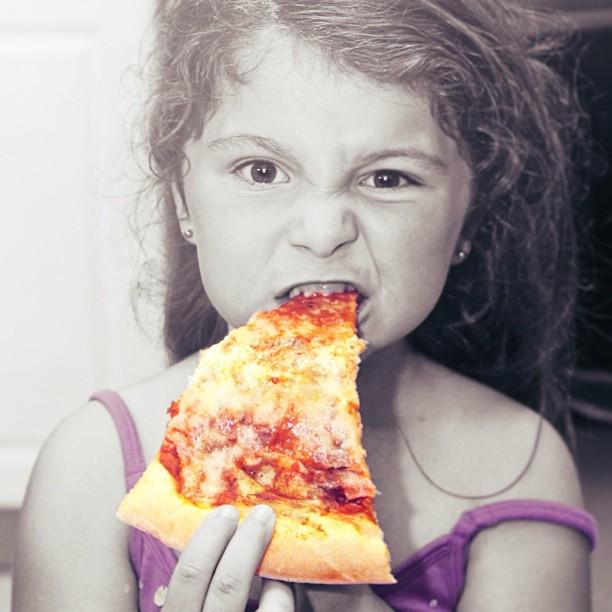Is the picture in full color?
Be succinct. No. Why is  this child biting down real hard on the pizza?
Short answer required. Yes. What kind of jewelry does the girl wear?
Answer briefly. Earrings. 